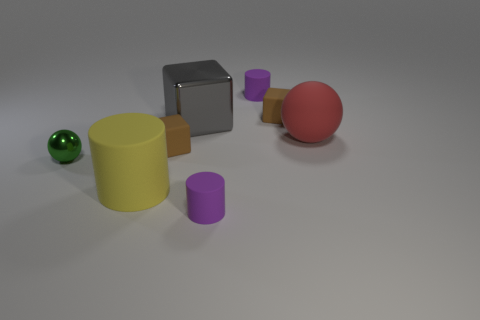How many tiny things are either spheres or yellow cylinders? In the image, there is one green sphere and no yellow cylinders. Therefore, the total count of tiny things that are either spheres or yellow cylinders is one. 